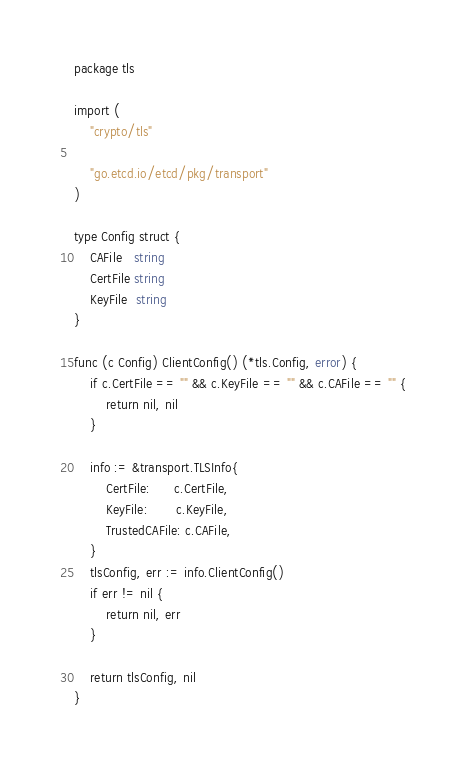Convert code to text. <code><loc_0><loc_0><loc_500><loc_500><_Go_>package tls

import (
	"crypto/tls"

	"go.etcd.io/etcd/pkg/transport"
)

type Config struct {
	CAFile   string
	CertFile string
	KeyFile  string
}

func (c Config) ClientConfig() (*tls.Config, error) {
	if c.CertFile == "" && c.KeyFile == "" && c.CAFile == "" {
		return nil, nil
	}

	info := &transport.TLSInfo{
		CertFile:      c.CertFile,
		KeyFile:       c.KeyFile,
		TrustedCAFile: c.CAFile,
	}
	tlsConfig, err := info.ClientConfig()
	if err != nil {
		return nil, err
	}

	return tlsConfig, nil
}
</code> 